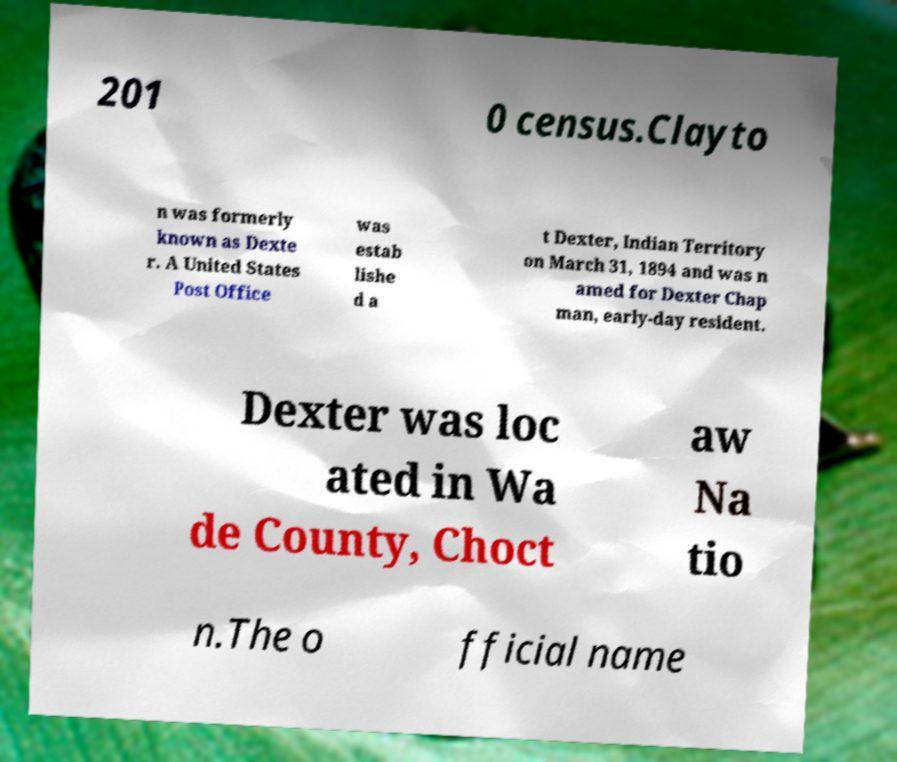Please read and relay the text visible in this image. What does it say? 201 0 census.Clayto n was formerly known as Dexte r. A United States Post Office was estab lishe d a t Dexter, Indian Territory on March 31, 1894 and was n amed for Dexter Chap man, early-day resident. Dexter was loc ated in Wa de County, Choct aw Na tio n.The o fficial name 